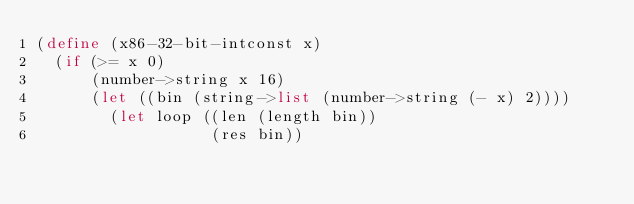Convert code to text. <code><loc_0><loc_0><loc_500><loc_500><_Scheme_>(define (x86-32-bit-intconst x)
  (if (>= x 0)
      (number->string x 16)
      (let ((bin (string->list (number->string (- x) 2))))
        (let loop ((len (length bin))
                   (res bin))</code> 